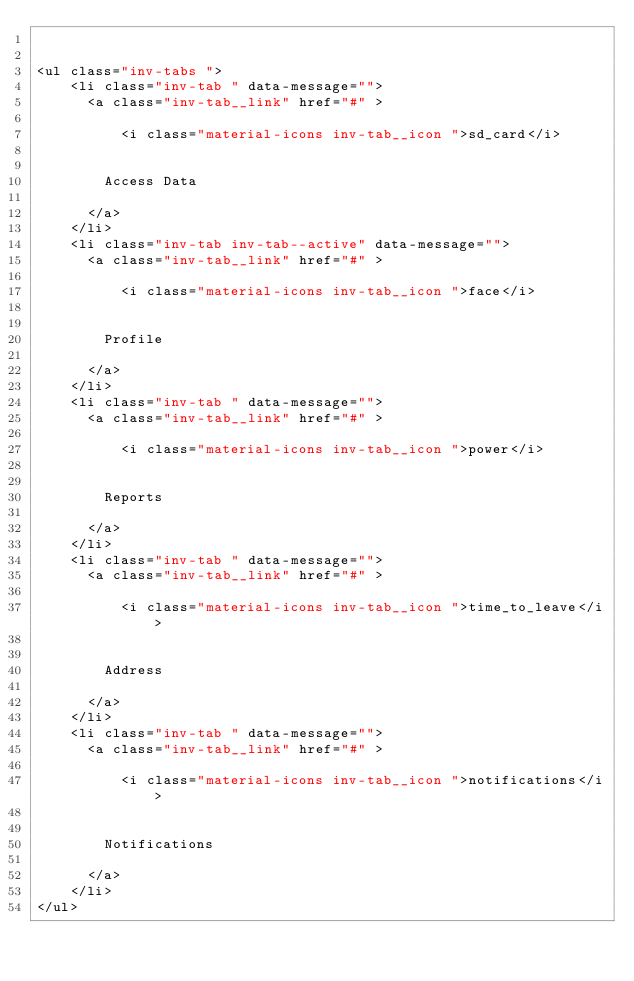Convert code to text. <code><loc_0><loc_0><loc_500><loc_500><_HTML_>

<ul class="inv-tabs ">
    <li class="inv-tab " data-message="">
      <a class="inv-tab__link" href="#" >

          <i class="material-icons inv-tab__icon ">sd_card</i>


        Access Data

      </a>
    </li>
    <li class="inv-tab inv-tab--active" data-message="">
      <a class="inv-tab__link" href="#" >

          <i class="material-icons inv-tab__icon ">face</i>


        Profile

      </a>
    </li>
    <li class="inv-tab " data-message="">
      <a class="inv-tab__link" href="#" >

          <i class="material-icons inv-tab__icon ">power</i>


        Reports

      </a>
    </li>
    <li class="inv-tab " data-message="">
      <a class="inv-tab__link" href="#" >

          <i class="material-icons inv-tab__icon ">time_to_leave</i>


        Address

      </a>
    </li>
    <li class="inv-tab " data-message="">
      <a class="inv-tab__link" href="#" >

          <i class="material-icons inv-tab__icon ">notifications</i>


        Notifications

      </a>
    </li>
</ul>
</code> 